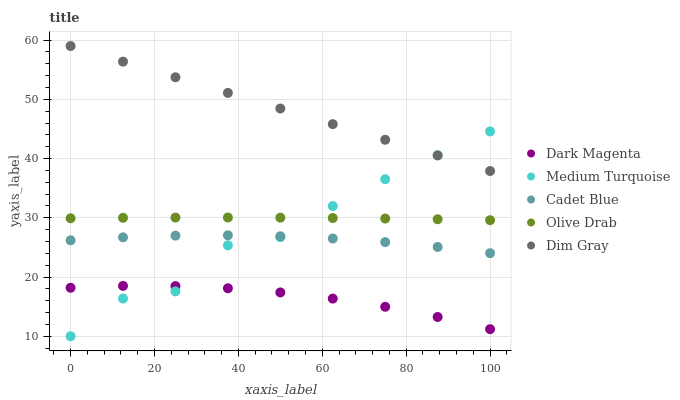Does Dark Magenta have the minimum area under the curve?
Answer yes or no. Yes. Does Dim Gray have the maximum area under the curve?
Answer yes or no. Yes. Does Cadet Blue have the minimum area under the curve?
Answer yes or no. No. Does Cadet Blue have the maximum area under the curve?
Answer yes or no. No. Is Dim Gray the smoothest?
Answer yes or no. Yes. Is Medium Turquoise the roughest?
Answer yes or no. Yes. Is Cadet Blue the smoothest?
Answer yes or no. No. Is Cadet Blue the roughest?
Answer yes or no. No. Does Medium Turquoise have the lowest value?
Answer yes or no. Yes. Does Cadet Blue have the lowest value?
Answer yes or no. No. Does Dim Gray have the highest value?
Answer yes or no. Yes. Does Cadet Blue have the highest value?
Answer yes or no. No. Is Dark Magenta less than Dim Gray?
Answer yes or no. Yes. Is Dim Gray greater than Dark Magenta?
Answer yes or no. Yes. Does Medium Turquoise intersect Cadet Blue?
Answer yes or no. Yes. Is Medium Turquoise less than Cadet Blue?
Answer yes or no. No. Is Medium Turquoise greater than Cadet Blue?
Answer yes or no. No. Does Dark Magenta intersect Dim Gray?
Answer yes or no. No. 